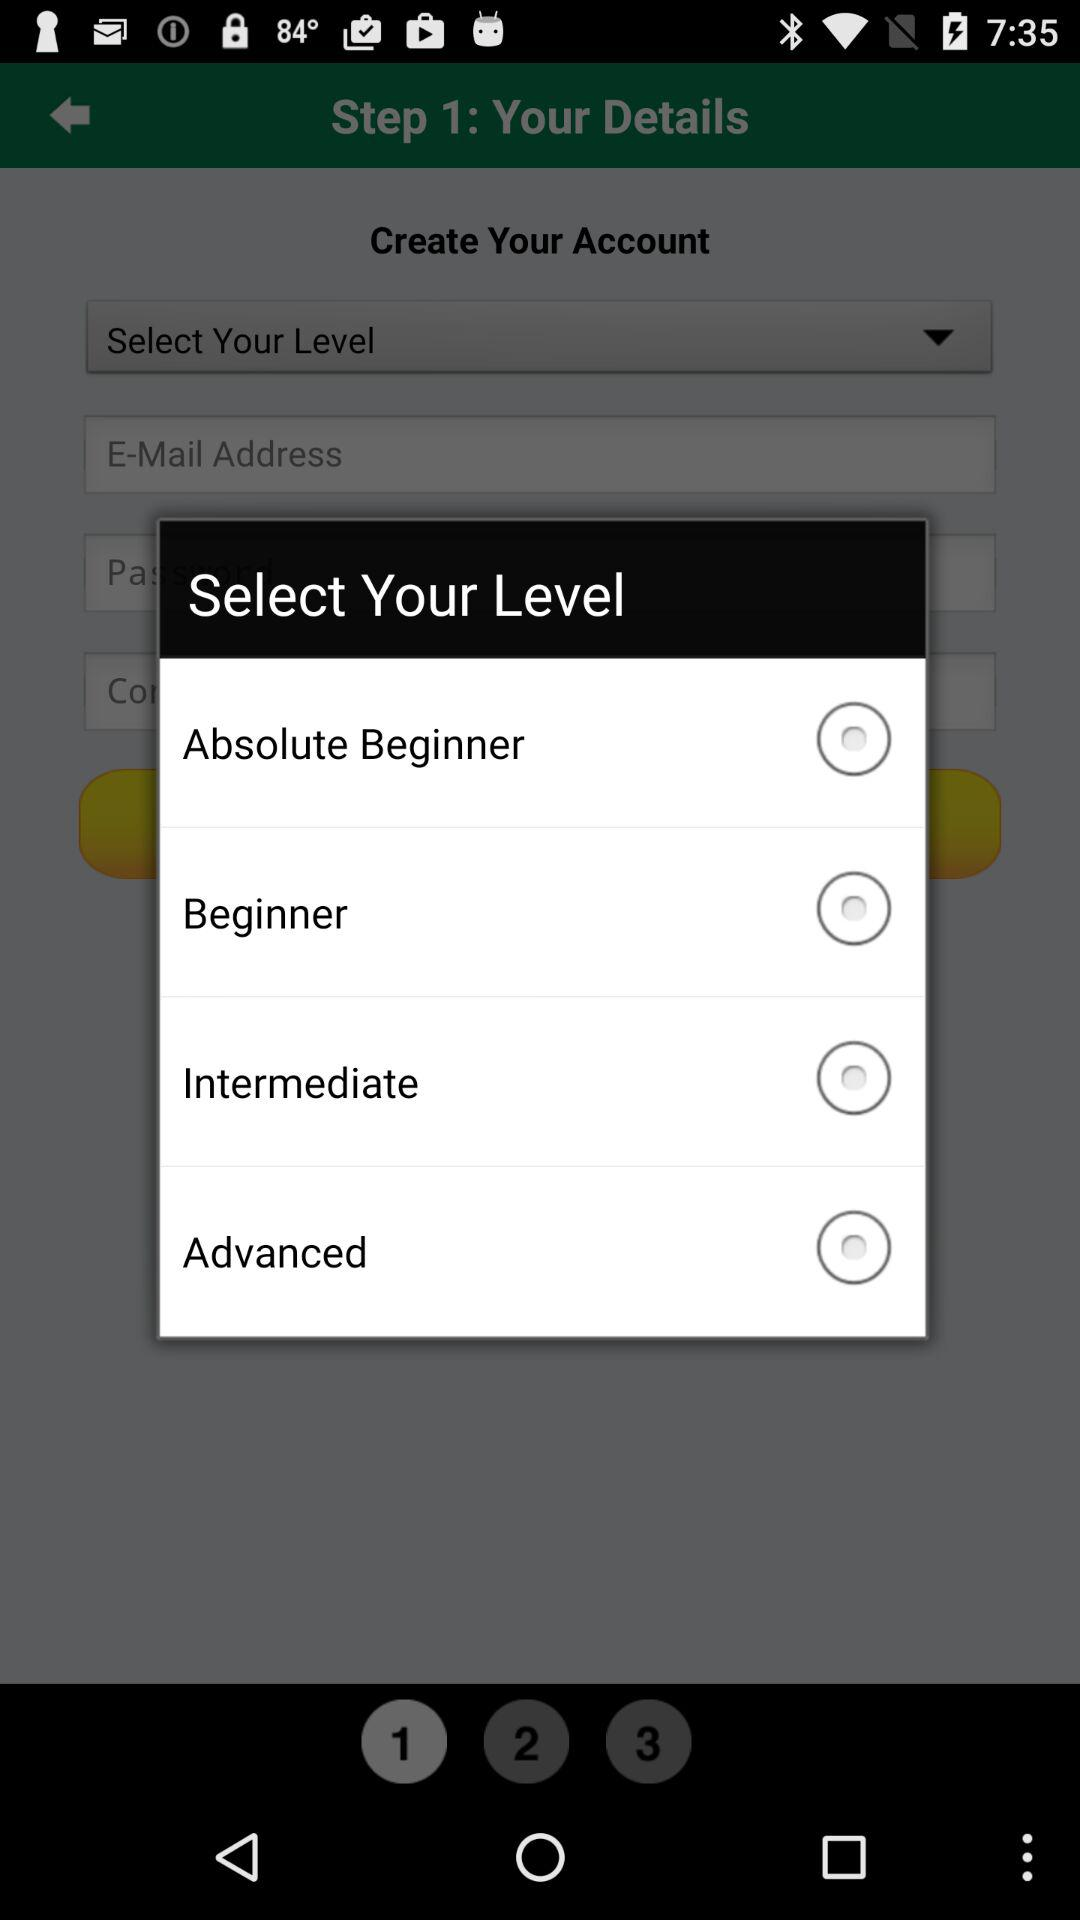What are the different level categories? The different level categories are "Absolute Beginner", "Beginner", "Intermediate" and "Advanced". 